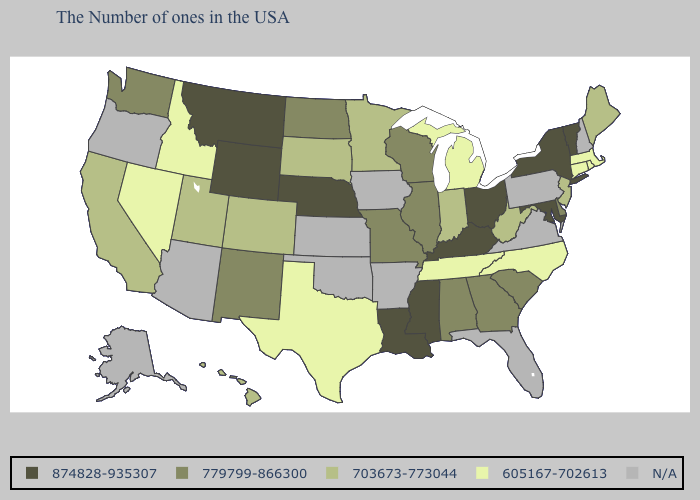Name the states that have a value in the range 874828-935307?
Short answer required. Vermont, New York, Maryland, Ohio, Kentucky, Mississippi, Louisiana, Nebraska, Wyoming, Montana. Does Hawaii have the lowest value in the USA?
Keep it brief. No. Which states have the highest value in the USA?
Concise answer only. Vermont, New York, Maryland, Ohio, Kentucky, Mississippi, Louisiana, Nebraska, Wyoming, Montana. Is the legend a continuous bar?
Keep it brief. No. Does West Virginia have the lowest value in the USA?
Answer briefly. No. Name the states that have a value in the range 779799-866300?
Write a very short answer. Delaware, South Carolina, Georgia, Alabama, Wisconsin, Illinois, Missouri, North Dakota, New Mexico, Washington. Name the states that have a value in the range 605167-702613?
Answer briefly. Massachusetts, Rhode Island, Connecticut, North Carolina, Michigan, Tennessee, Texas, Idaho, Nevada. Among the states that border New York , does Connecticut have the lowest value?
Concise answer only. Yes. Does the first symbol in the legend represent the smallest category?
Answer briefly. No. What is the highest value in the West ?
Write a very short answer. 874828-935307. What is the highest value in states that border Arizona?
Write a very short answer. 779799-866300. Name the states that have a value in the range 703673-773044?
Give a very brief answer. Maine, New Jersey, West Virginia, Indiana, Minnesota, South Dakota, Colorado, Utah, California, Hawaii. What is the value of Maine?
Quick response, please. 703673-773044. What is the value of New Mexico?
Concise answer only. 779799-866300. 